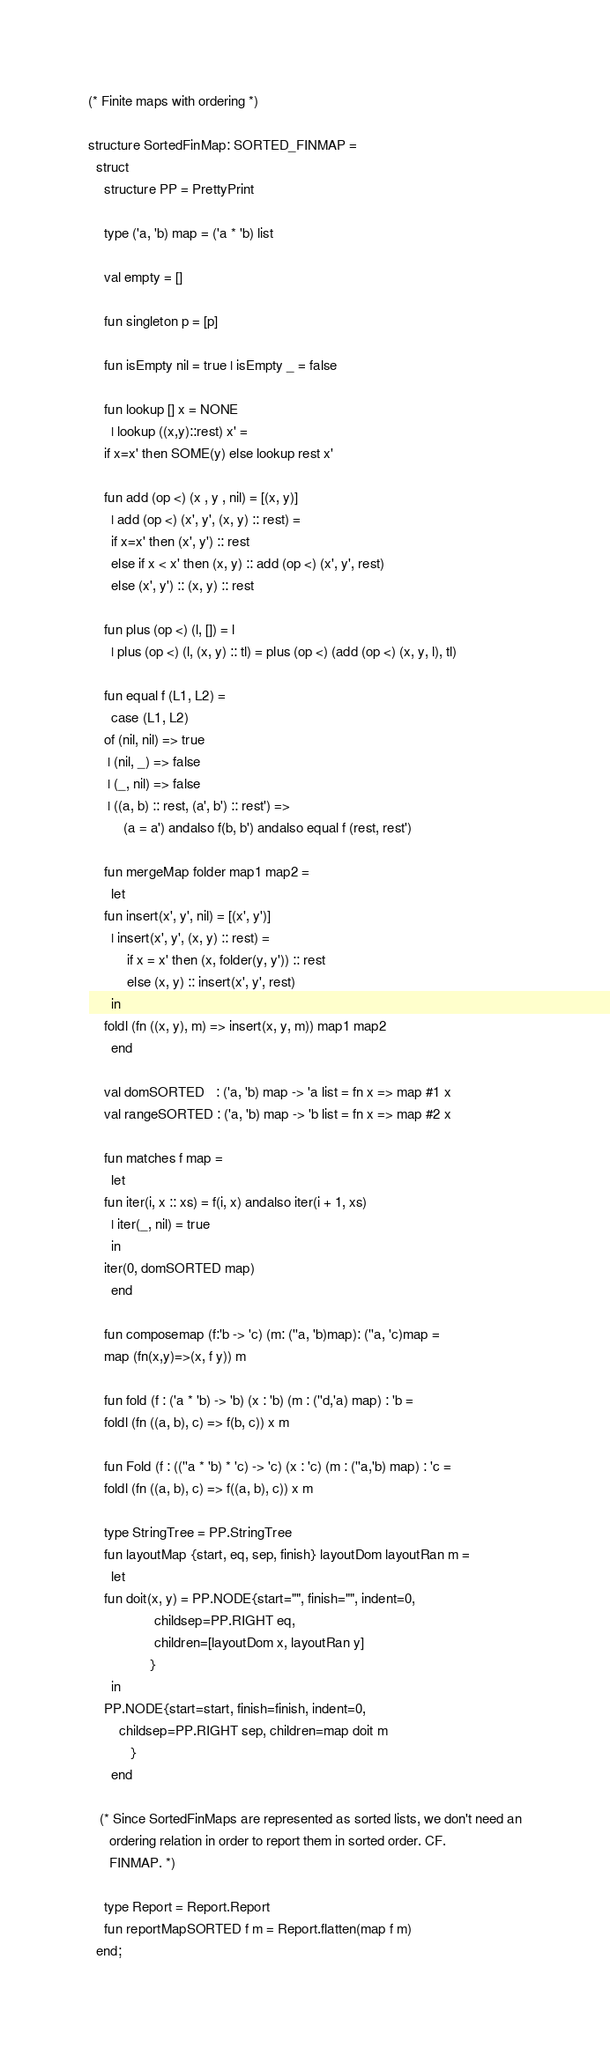Convert code to text. <code><loc_0><loc_0><loc_500><loc_500><_SML_>(* Finite maps with ordering *)

structure SortedFinMap: SORTED_FINMAP =
  struct
    structure PP = PrettyPrint

    type ('a, 'b) map = ('a * 'b) list

    val empty = []

    fun singleton p = [p]

    fun isEmpty nil = true | isEmpty _ = false

    fun lookup [] x = NONE
      | lookup ((x,y)::rest) x' =
	if x=x' then SOME(y) else lookup rest x'

    fun add (op <) (x , y , nil) = [(x, y)]
      | add (op <) (x', y', (x, y) :: rest) = 
	  if x=x' then (x', y') :: rest
	  else if x < x' then (x, y) :: add (op <) (x', y', rest)
	  else (x', y') :: (x, y) :: rest

    fun plus (op <) (l, []) = l
      | plus (op <) (l, (x, y) :: tl) = plus (op <) (add (op <) (x, y, l), tl)

    fun equal f (L1, L2) =
      case (L1, L2)
	of (nil, nil) => true
	 | (nil, _) => false
	 | (_, nil) => false
	 | ((a, b) :: rest, (a', b') :: rest') =>
	     (a = a') andalso f(b, b') andalso equal f (rest, rest')

    fun mergeMap folder map1 map2 =
      let
	fun insert(x', y', nil) = [(x', y')]
	  | insert(x', y', (x, y) :: rest) =
	      if x = x' then (x, folder(y, y')) :: rest
	      else (x, y) :: insert(x', y', rest)
      in
	foldl (fn ((x, y), m) => insert(x, y, m)) map1 map2
      end

    val domSORTED   : ('a, 'b) map -> 'a list = fn x => map #1 x
    val rangeSORTED : ('a, 'b) map -> 'b list = fn x => map #2 x

    fun matches f map =
      let
	fun iter(i, x :: xs) = f(i, x) andalso iter(i + 1, xs)
	  | iter(_, nil) = true
      in
	iter(0, domSORTED map)
      end

    fun composemap (f:'b -> 'c) (m: (''a, 'b)map): (''a, 'c)map = 
	map (fn(x,y)=>(x, f y)) m

    fun fold (f : ('a * 'b) -> 'b) (x : 'b) (m : (''d,'a) map) : 'b = 
	foldl (fn ((a, b), c) => f(b, c)) x m

    fun Fold (f : ((''a * 'b) * 'c) -> 'c) (x : 'c) (m : (''a,'b) map) : 'c =
	foldl (fn ((a, b), c) => f((a, b), c)) x m

    type StringTree = PP.StringTree
    fun layoutMap {start, eq, sep, finish} layoutDom layoutRan m =
      let
	fun doit(x, y) = PP.NODE{start="", finish="", indent=0,
				 childsep=PP.RIGHT eq,
				 children=[layoutDom x, layoutRan y]
				}
      in
	PP.NODE{start=start, finish=finish, indent=0,
		childsep=PP.RIGHT sep, children=map doit m
	       }
      end

   (* Since SortedFinMaps are represented as sorted lists, we don't need an
      ordering relation in order to report them in sorted order. CF.
      FINMAP. *)

    type Report = Report.Report
    fun reportMapSORTED f m = Report.flatten(map f m)
  end;
</code> 